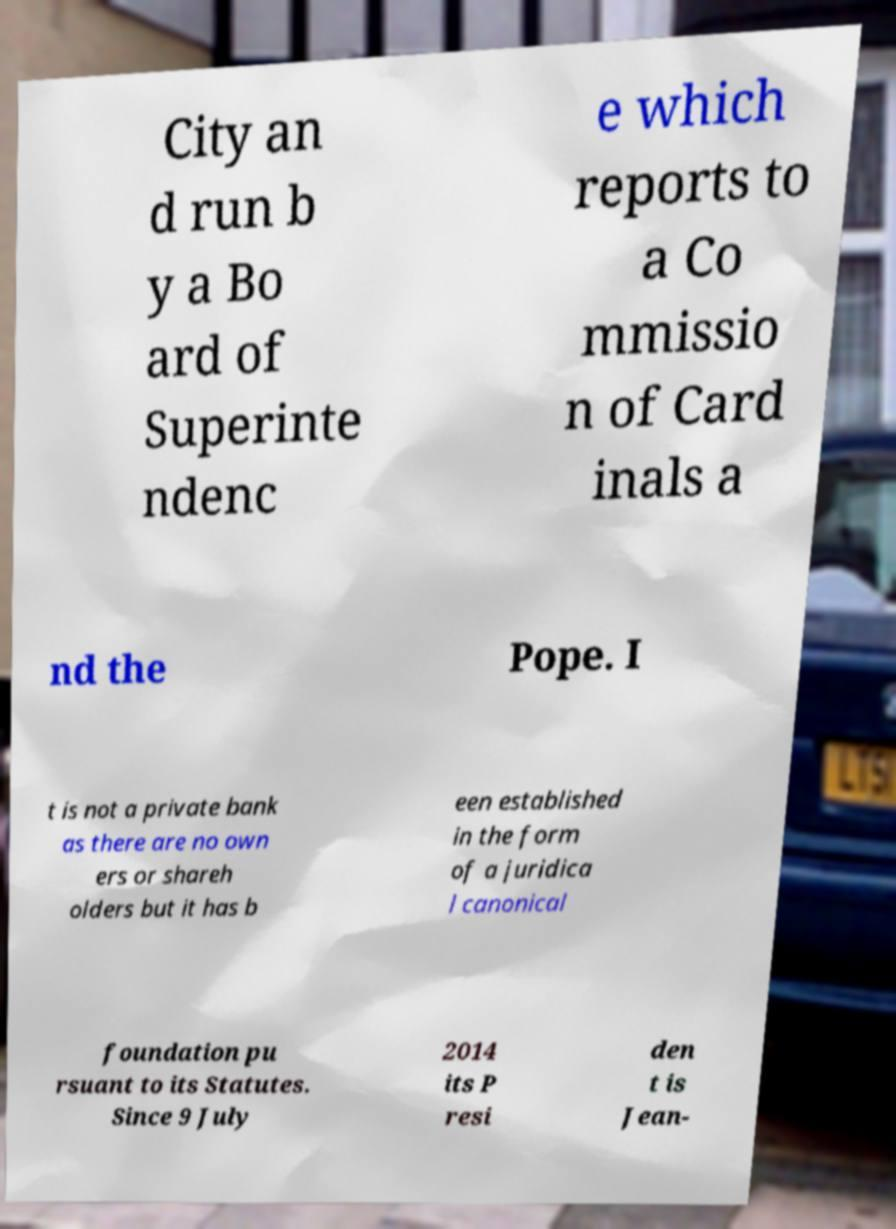Please read and relay the text visible in this image. What does it say? City an d run b y a Bo ard of Superinte ndenc e which reports to a Co mmissio n of Card inals a nd the Pope. I t is not a private bank as there are no own ers or shareh olders but it has b een established in the form of a juridica l canonical foundation pu rsuant to its Statutes. Since 9 July 2014 its P resi den t is Jean- 